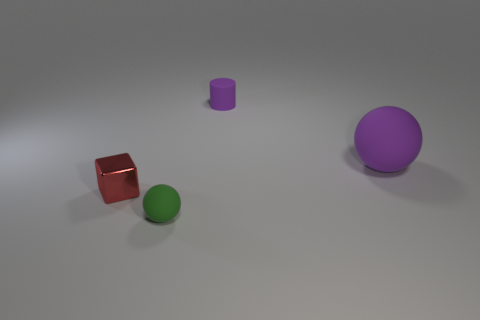Add 2 blue rubber cubes. How many objects exist? 6 Subtract all blocks. How many objects are left? 3 Subtract 0 cyan spheres. How many objects are left? 4 Subtract all big balls. Subtract all red metal blocks. How many objects are left? 2 Add 2 small green matte spheres. How many small green matte spheres are left? 3 Add 4 tiny yellow metal spheres. How many tiny yellow metal spheres exist? 4 